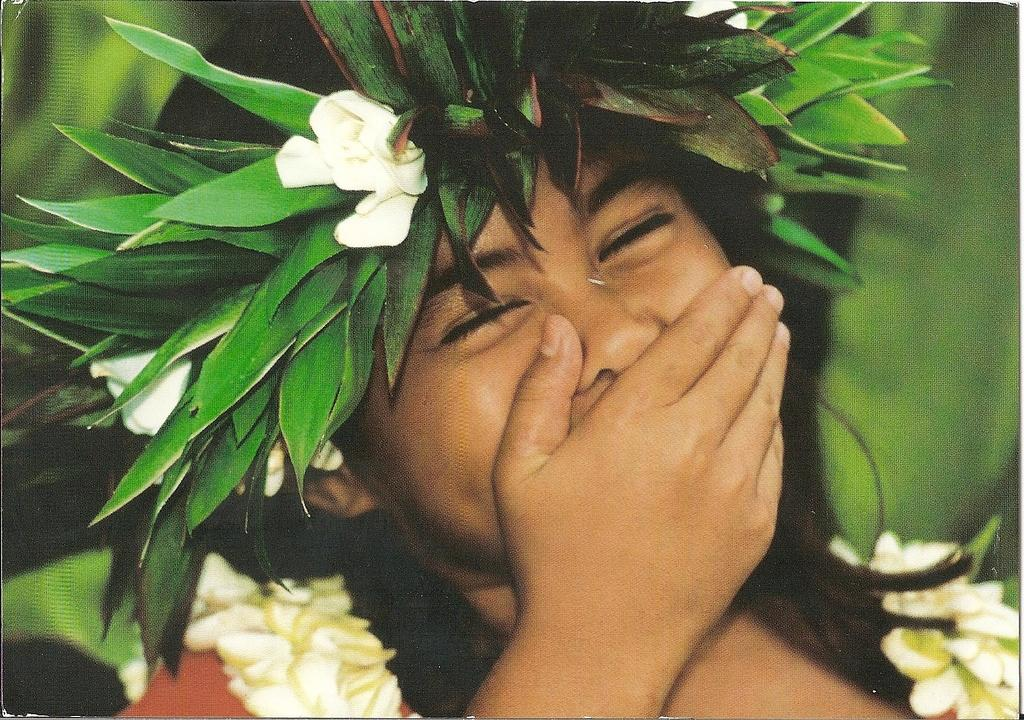Who is the main subject in the image? There is a girl in the image. What is the girl doing with her hand? The girl is covering her mouth with her hand. What can be seen above the girl in the image? There are flowers above the girl in the image. How would you describe the background of the image? The background of the image is blurry. What type of jelly is visible on the calendar in the image? There is no jelly or calendar present in the image. In what position is the girl sitting in the image? The position of the girl cannot be determined from the provided facts, as there is no information about her sitting or standing. 